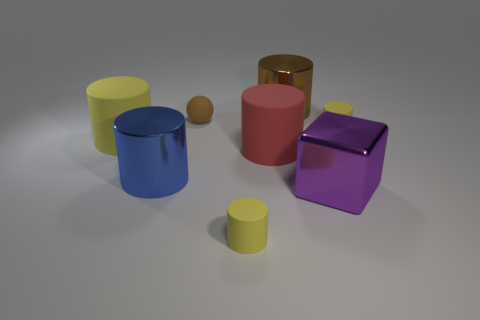Can you describe the lighting in the scene? The scene is illuminated from above with a soft, diffused light that casts gentle shadows beneath the objects. The lighting appears even and does not seem to create any harsh contrasts or bright spots on surfaces. 